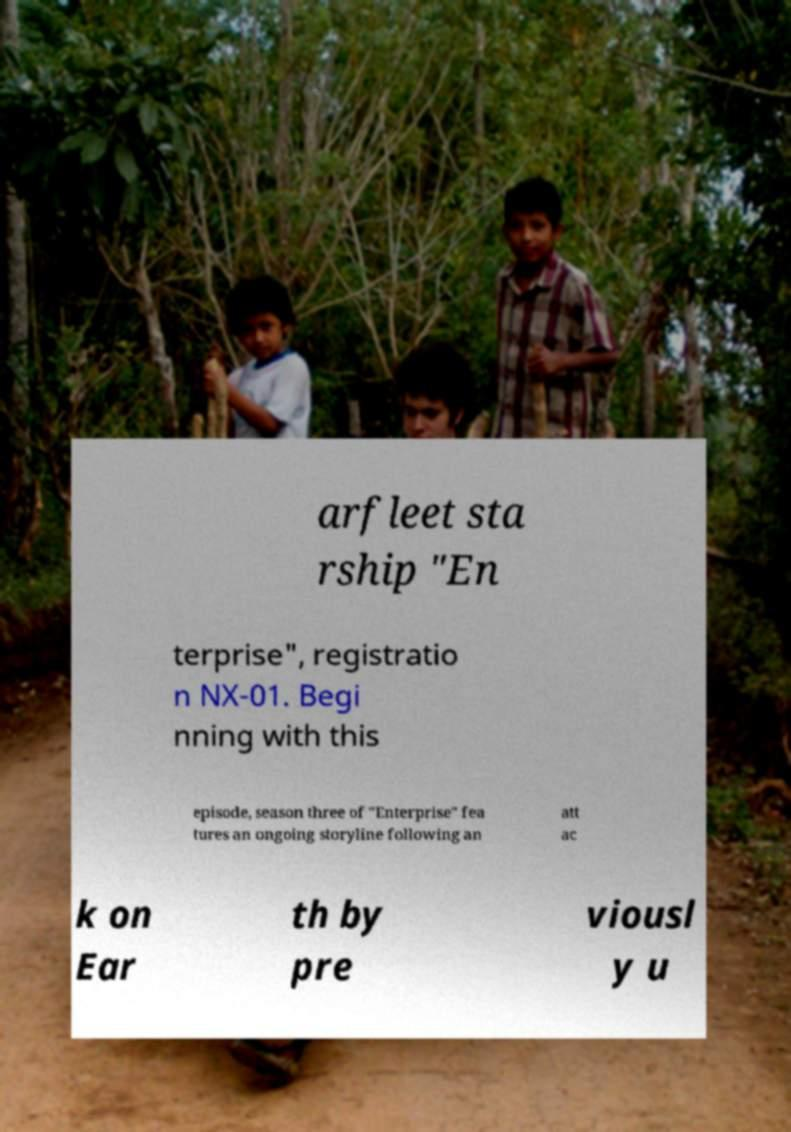There's text embedded in this image that I need extracted. Can you transcribe it verbatim? arfleet sta rship "En terprise", registratio n NX-01. Begi nning with this episode, season three of "Enterprise" fea tures an ongoing storyline following an att ac k on Ear th by pre viousl y u 